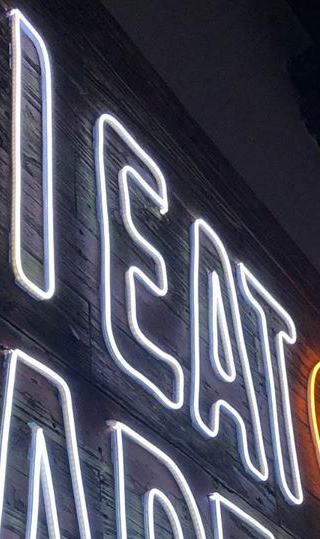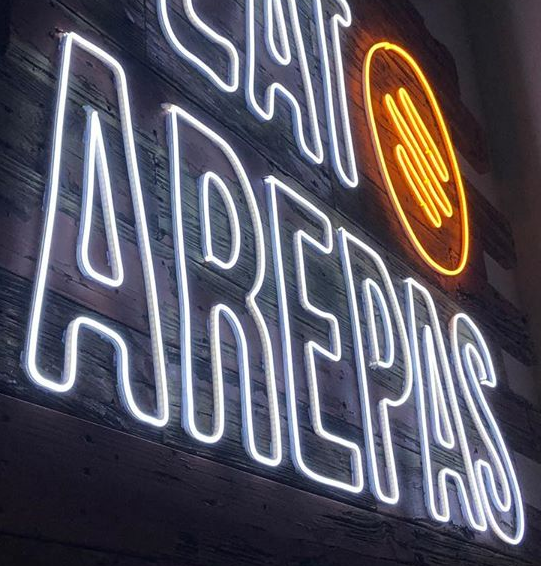Transcribe the words shown in these images in order, separated by a semicolon. IEAT; AREPAS 